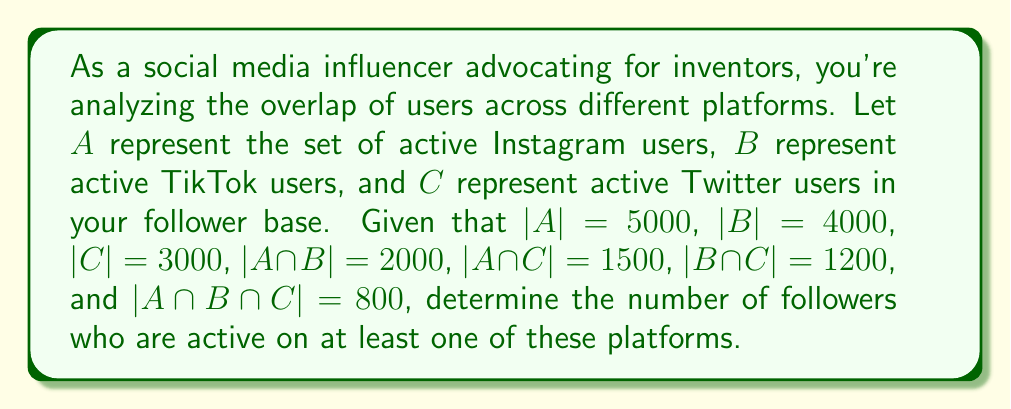Teach me how to tackle this problem. To solve this problem, we'll use the Inclusion-Exclusion Principle for three sets:

$|A \cup B \cup C| = |A| + |B| + |C| - |A \cap B| - |A \cap C| - |B \cap C| + |A \cap B \cap C|$

Let's substitute the given values:

$|A \cup B \cup C| = 5000 + 4000 + 3000 - 2000 - 1500 - 1200 + 800$

Now, let's calculate step by step:

1) First, add the individual set sizes:
   $5000 + 4000 + 3000 = 12000$

2) Subtract the pairwise intersections:
   $12000 - 2000 - 1500 - 1200 = 7300$

3) Add back the triple intersection:
   $7300 + 800 = 8100$

Therefore, the number of followers who are active on at least one of these platforms is 8100.
Answer: $|A \cup B \cup C| = 8100$ followers 